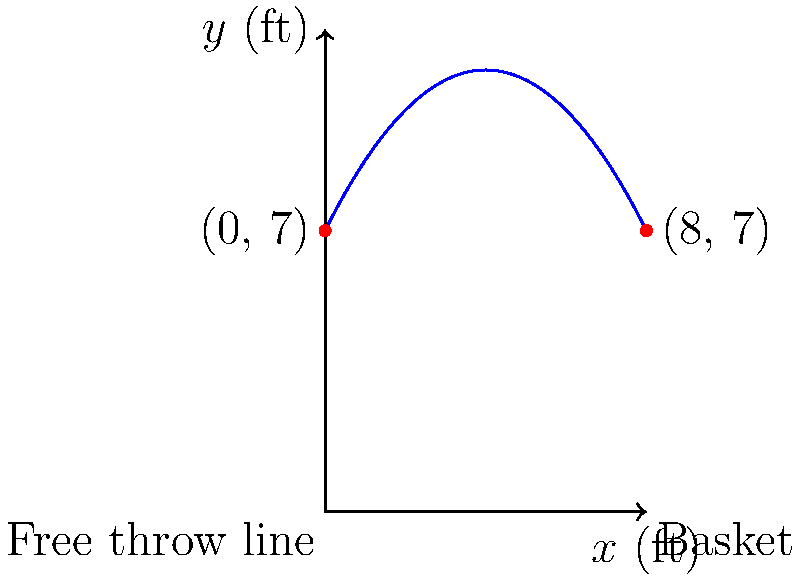As a basketball enthusiast, you're analyzing the trajectory of a free throw. The path of the ball can be modeled by the parabolic function $f(x) = -0.25x^2 + 2x + 7$, where $x$ is the horizontal distance from the free throw line in feet, and $f(x)$ is the height of the ball in feet. The free throw line is 15 feet from the backboard, and the hoop is 10 feet high. What is the maximum height reached by the ball during its flight? To find the maximum height of the ball's trajectory, we need to follow these steps:

1) The parabola's axis of symmetry occurs at the vertex, which is the highest point of the parabola.

2) For a quadratic function in the form $f(x) = ax^2 + bx + c$, the x-coordinate of the vertex is given by $x = -\frac{b}{2a}$.

3) In our function $f(x) = -0.25x^2 + 2x + 7$:
   $a = -0.25$
   $b = 2$
   $c = 7$

4) Calculating the x-coordinate of the vertex:
   $x = -\frac{b}{2a} = -\frac{2}{2(-0.25)} = -\frac{2}{-0.5} = 4$ feet

5) To find the maximum height, we substitute this x-value back into our original function:

   $f(4) = -0.25(4)^2 + 2(4) + 7$
         $= -0.25(16) + 8 + 7$
         $= -4 + 8 + 7$
         $= 11$ feet

Therefore, the maximum height reached by the ball during its flight is 11 feet.
Answer: 11 feet 